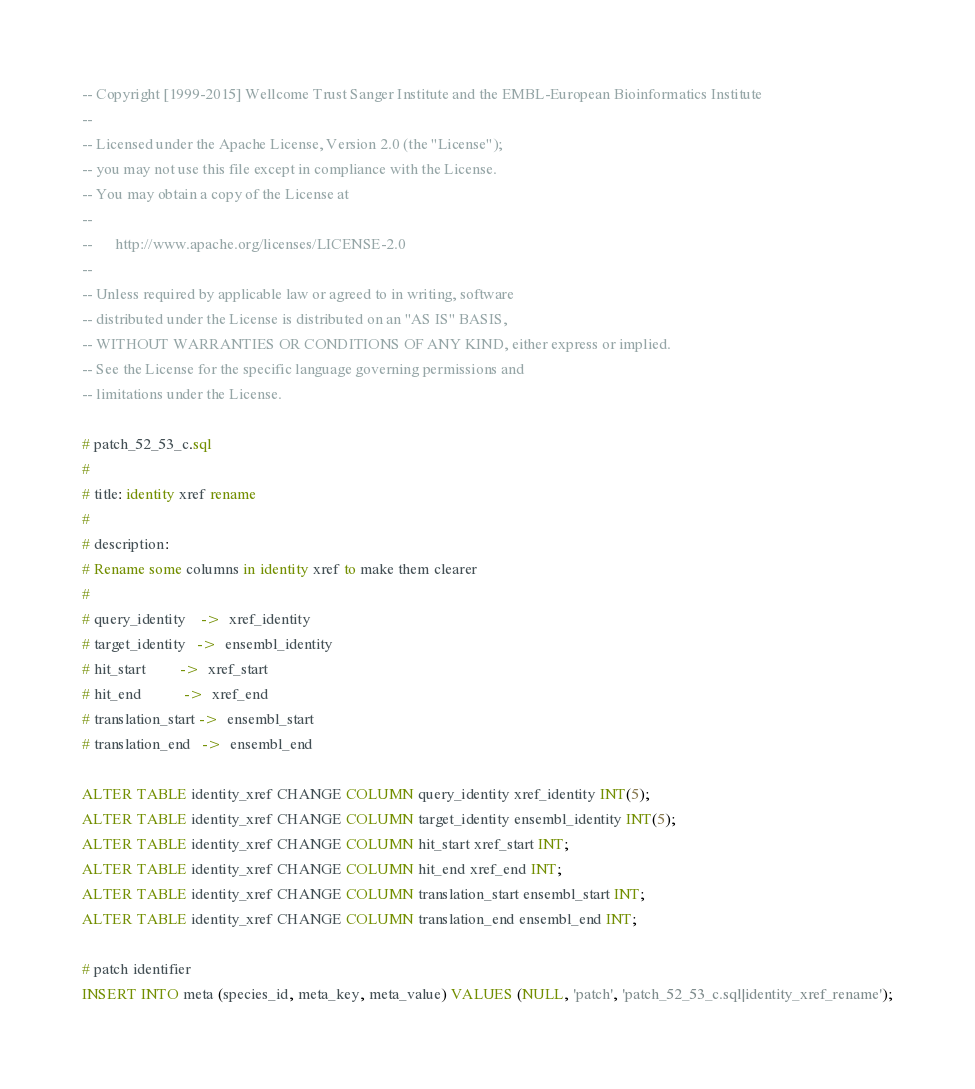<code> <loc_0><loc_0><loc_500><loc_500><_SQL_>-- Copyright [1999-2015] Wellcome Trust Sanger Institute and the EMBL-European Bioinformatics Institute
-- 
-- Licensed under the Apache License, Version 2.0 (the "License");
-- you may not use this file except in compliance with the License.
-- You may obtain a copy of the License at
-- 
--      http://www.apache.org/licenses/LICENSE-2.0
-- 
-- Unless required by applicable law or agreed to in writing, software
-- distributed under the License is distributed on an "AS IS" BASIS,
-- WITHOUT WARRANTIES OR CONDITIONS OF ANY KIND, either express or implied.
-- See the License for the specific language governing permissions and
-- limitations under the License.

# patch_52_53_c.sql
#
# title: identity xref rename
#
# description:
# Rename some columns in identity xref to make them clearer
#
# query_identity    ->  xref_identity
# target_identity   ->  ensembl_identity
# hit_start         ->  xref_start
# hit_end           ->  xref_end
# translation_start ->  ensembl_start
# translation_end   ->  ensembl_end

ALTER TABLE identity_xref CHANGE COLUMN query_identity xref_identity INT(5);
ALTER TABLE identity_xref CHANGE COLUMN target_identity ensembl_identity INT(5);
ALTER TABLE identity_xref CHANGE COLUMN hit_start xref_start INT;
ALTER TABLE identity_xref CHANGE COLUMN hit_end xref_end INT;
ALTER TABLE identity_xref CHANGE COLUMN translation_start ensembl_start INT;
ALTER TABLE identity_xref CHANGE COLUMN translation_end ensembl_end INT;

# patch identifier
INSERT INTO meta (species_id, meta_key, meta_value) VALUES (NULL, 'patch', 'patch_52_53_c.sql|identity_xref_rename');


</code> 